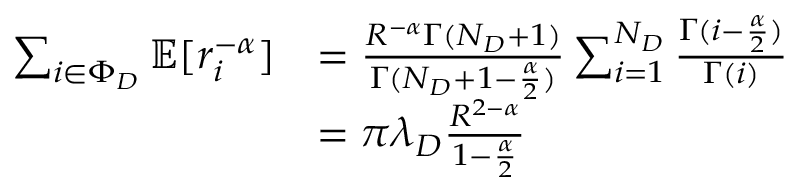Convert formula to latex. <formula><loc_0><loc_0><loc_500><loc_500>\begin{array} { r l } { \sum _ { i \in \Phi _ { D } } \mathbb { E } [ r _ { i } ^ { - \alpha } ] } & { = \frac { R ^ { - \alpha } \Gamma ( N _ { D } + 1 ) } { \Gamma ( N _ { D } + 1 - \frac { \alpha } { 2 } ) } \sum _ { i = 1 } ^ { N _ { D } } \frac { \Gamma ( i - \frac { \alpha } { 2 } ) } { \Gamma ( i ) } } \\ & { = \pi \lambda _ { D } \frac { R ^ { 2 - \alpha } } { 1 - \frac { \alpha } { 2 } } } \end{array}</formula> 